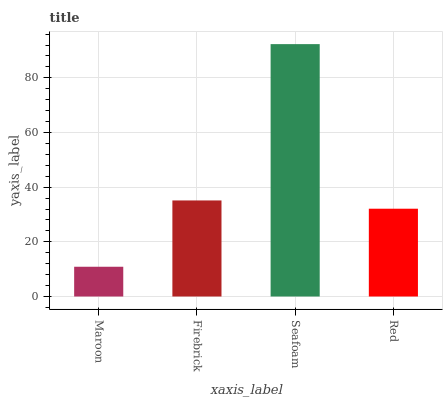Is Maroon the minimum?
Answer yes or no. Yes. Is Seafoam the maximum?
Answer yes or no. Yes. Is Firebrick the minimum?
Answer yes or no. No. Is Firebrick the maximum?
Answer yes or no. No. Is Firebrick greater than Maroon?
Answer yes or no. Yes. Is Maroon less than Firebrick?
Answer yes or no. Yes. Is Maroon greater than Firebrick?
Answer yes or no. No. Is Firebrick less than Maroon?
Answer yes or no. No. Is Firebrick the high median?
Answer yes or no. Yes. Is Red the low median?
Answer yes or no. Yes. Is Maroon the high median?
Answer yes or no. No. Is Seafoam the low median?
Answer yes or no. No. 